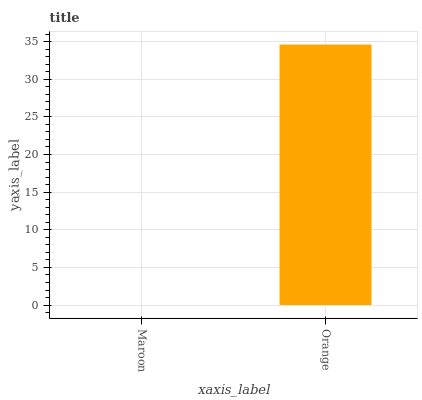Is Maroon the minimum?
Answer yes or no. Yes. Is Orange the maximum?
Answer yes or no. Yes. Is Orange the minimum?
Answer yes or no. No. Is Orange greater than Maroon?
Answer yes or no. Yes. Is Maroon less than Orange?
Answer yes or no. Yes. Is Maroon greater than Orange?
Answer yes or no. No. Is Orange less than Maroon?
Answer yes or no. No. Is Orange the high median?
Answer yes or no. Yes. Is Maroon the low median?
Answer yes or no. Yes. Is Maroon the high median?
Answer yes or no. No. Is Orange the low median?
Answer yes or no. No. 